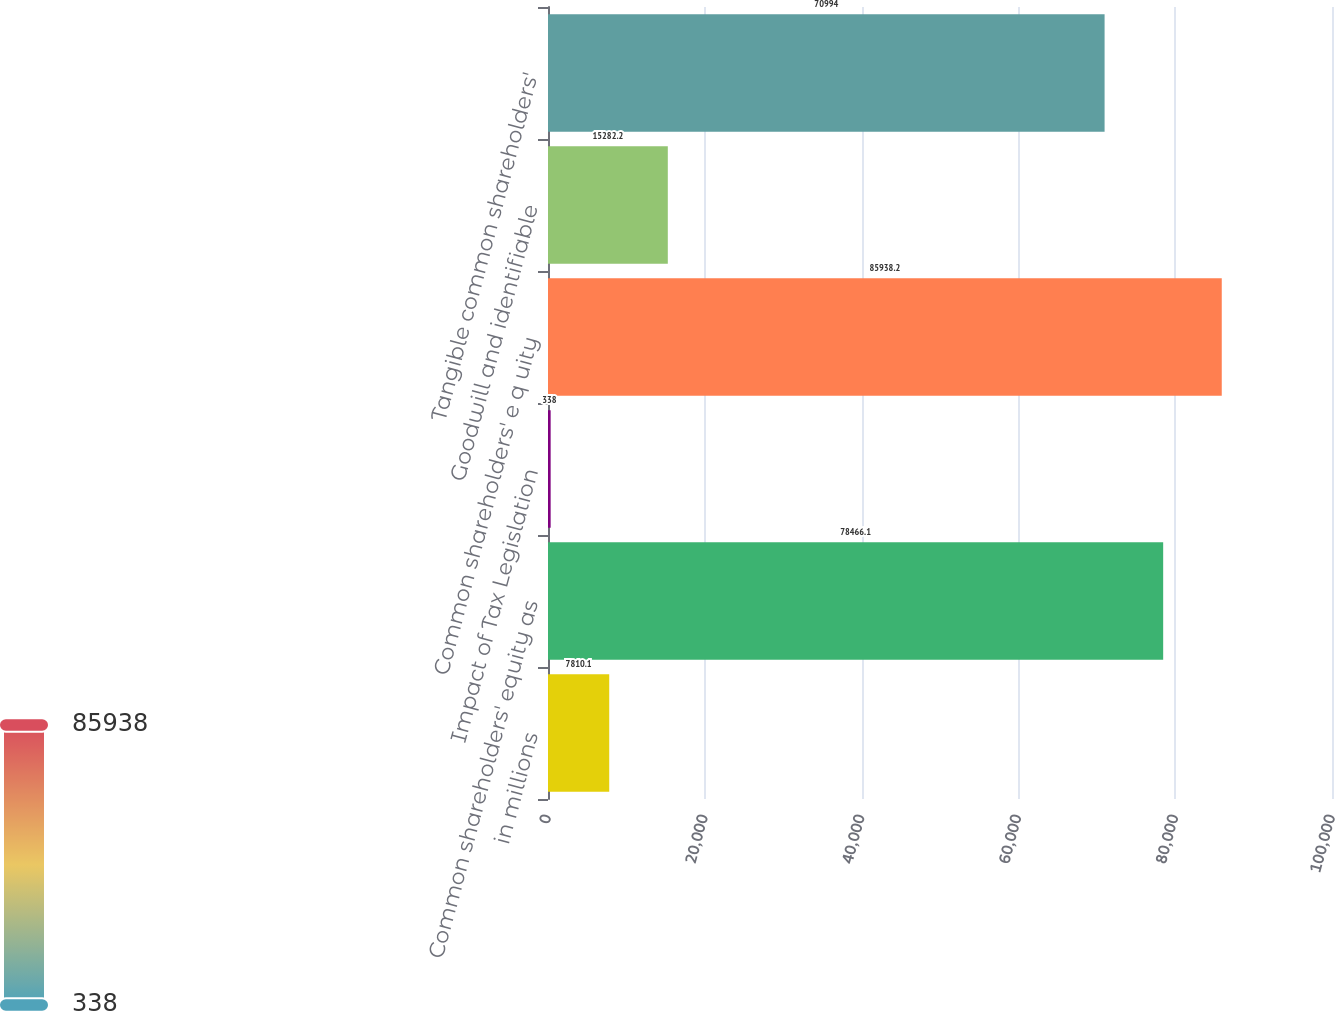Convert chart. <chart><loc_0><loc_0><loc_500><loc_500><bar_chart><fcel>in millions<fcel>Common shareholders' equity as<fcel>Impact of Tax Legislation<fcel>Common shareholders' e q uity<fcel>Goodwill and identifiable<fcel>Tangible common shareholders'<nl><fcel>7810.1<fcel>78466.1<fcel>338<fcel>85938.2<fcel>15282.2<fcel>70994<nl></chart> 